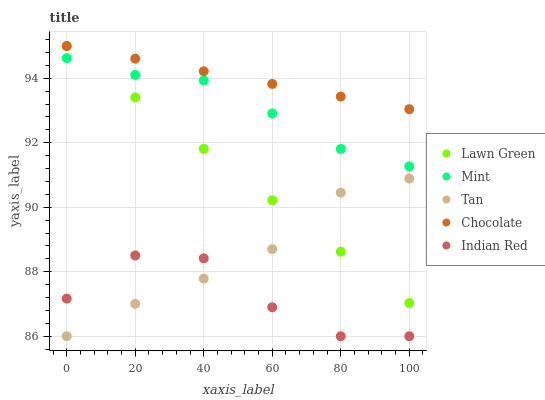Does Indian Red have the minimum area under the curve?
Answer yes or no. Yes. Does Chocolate have the maximum area under the curve?
Answer yes or no. Yes. Does Tan have the minimum area under the curve?
Answer yes or no. No. Does Tan have the maximum area under the curve?
Answer yes or no. No. Is Chocolate the smoothest?
Answer yes or no. Yes. Is Indian Red the roughest?
Answer yes or no. Yes. Is Tan the smoothest?
Answer yes or no. No. Is Tan the roughest?
Answer yes or no. No. Does Tan have the lowest value?
Answer yes or no. Yes. Does Mint have the lowest value?
Answer yes or no. No. Does Chocolate have the highest value?
Answer yes or no. Yes. Does Tan have the highest value?
Answer yes or no. No. Is Tan less than Mint?
Answer yes or no. Yes. Is Mint greater than Tan?
Answer yes or no. Yes. Does Lawn Green intersect Chocolate?
Answer yes or no. Yes. Is Lawn Green less than Chocolate?
Answer yes or no. No. Is Lawn Green greater than Chocolate?
Answer yes or no. No. Does Tan intersect Mint?
Answer yes or no. No. 